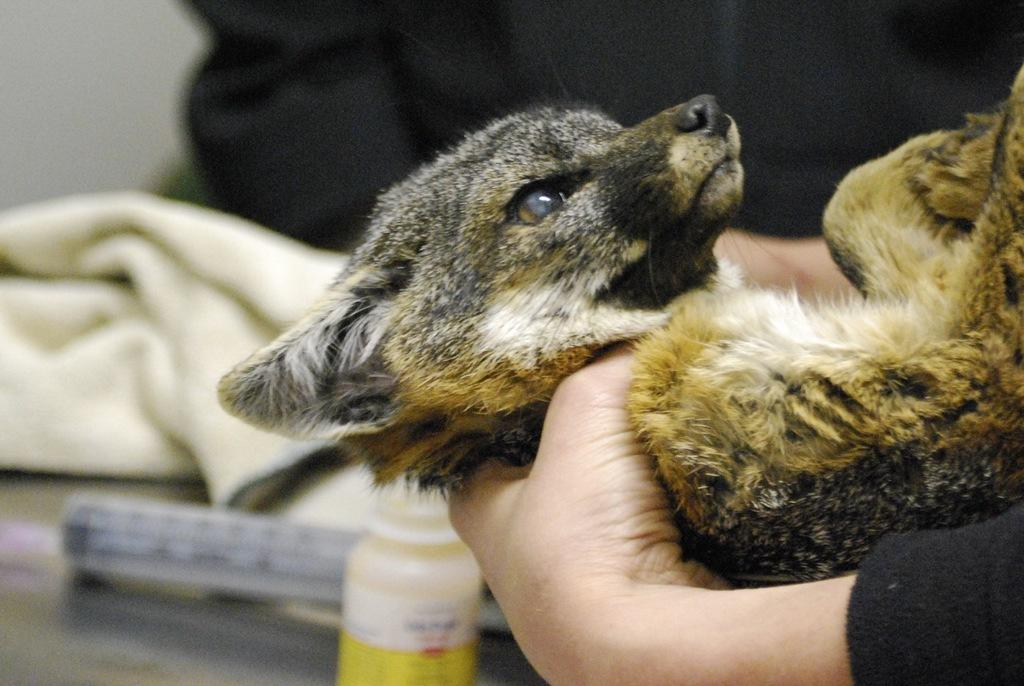What type of creature is in the image? There is an animal in the image. Can you describe the animal's location in the image? The animal is in a person's hand. What type of bag is the animal using to carry the group in the image? There is no bag or group present in the image; it only features an animal in a person's hand. 